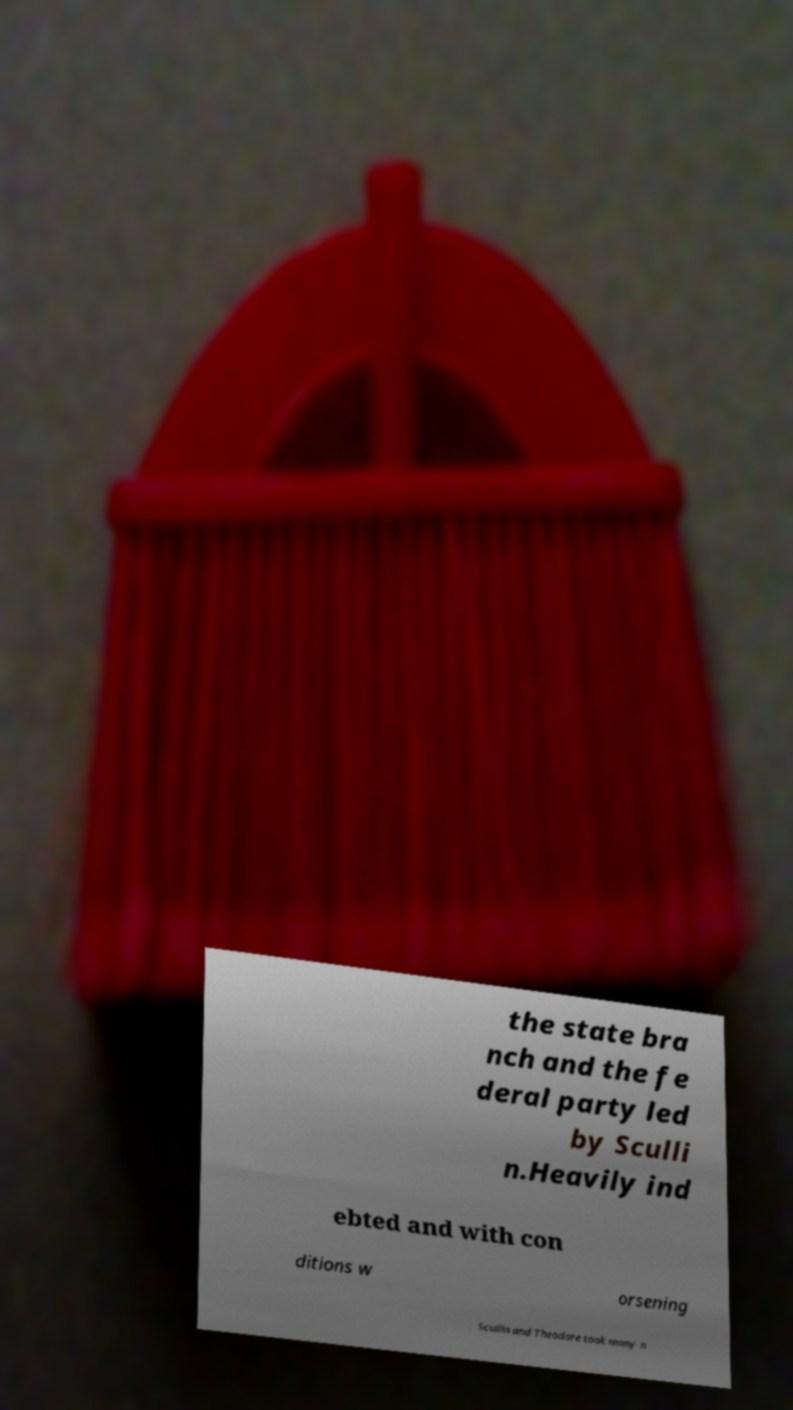There's text embedded in this image that I need extracted. Can you transcribe it verbatim? the state bra nch and the fe deral party led by Sculli n.Heavily ind ebted and with con ditions w orsening Scullin and Theodore took many n 